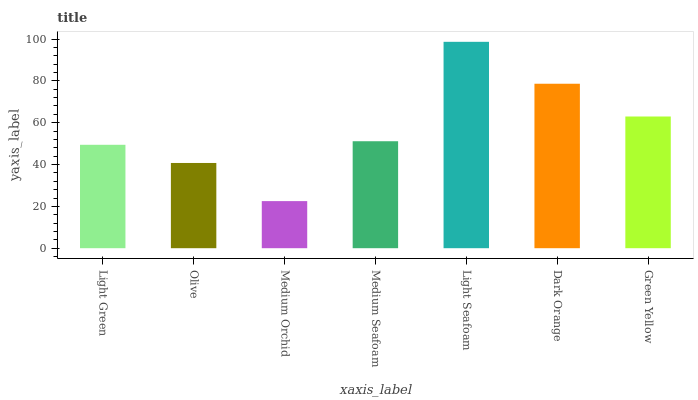Is Medium Orchid the minimum?
Answer yes or no. Yes. Is Light Seafoam the maximum?
Answer yes or no. Yes. Is Olive the minimum?
Answer yes or no. No. Is Olive the maximum?
Answer yes or no. No. Is Light Green greater than Olive?
Answer yes or no. Yes. Is Olive less than Light Green?
Answer yes or no. Yes. Is Olive greater than Light Green?
Answer yes or no. No. Is Light Green less than Olive?
Answer yes or no. No. Is Medium Seafoam the high median?
Answer yes or no. Yes. Is Medium Seafoam the low median?
Answer yes or no. Yes. Is Dark Orange the high median?
Answer yes or no. No. Is Light Green the low median?
Answer yes or no. No. 